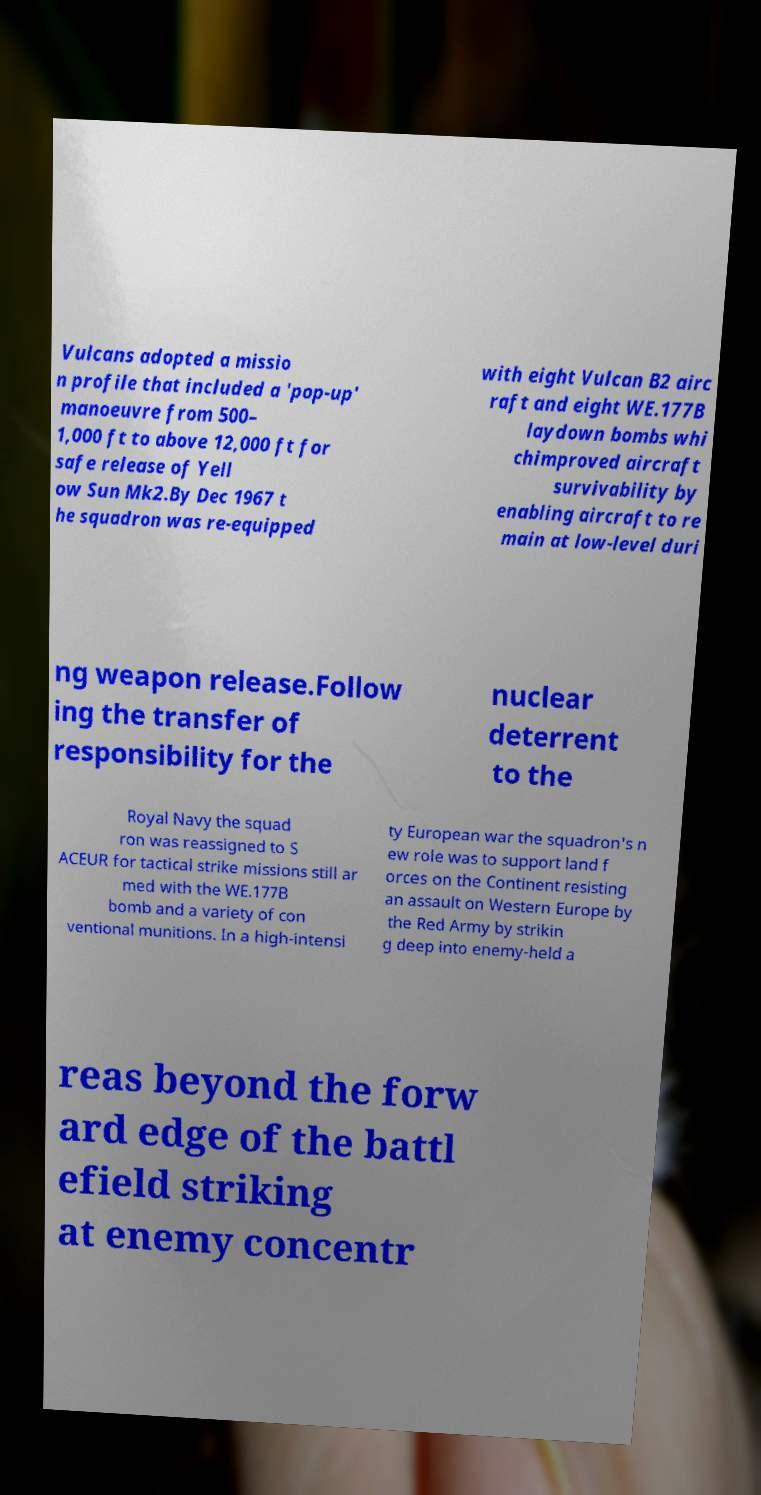Please identify and transcribe the text found in this image. Vulcans adopted a missio n profile that included a 'pop-up' manoeuvre from 500– 1,000 ft to above 12,000 ft for safe release of Yell ow Sun Mk2.By Dec 1967 t he squadron was re-equipped with eight Vulcan B2 airc raft and eight WE.177B laydown bombs whi chimproved aircraft survivability by enabling aircraft to re main at low-level duri ng weapon release.Follow ing the transfer of responsibility for the nuclear deterrent to the Royal Navy the squad ron was reassigned to S ACEUR for tactical strike missions still ar med with the WE.177B bomb and a variety of con ventional munitions. In a high-intensi ty European war the squadron's n ew role was to support land f orces on the Continent resisting an assault on Western Europe by the Red Army by strikin g deep into enemy-held a reas beyond the forw ard edge of the battl efield striking at enemy concentr 